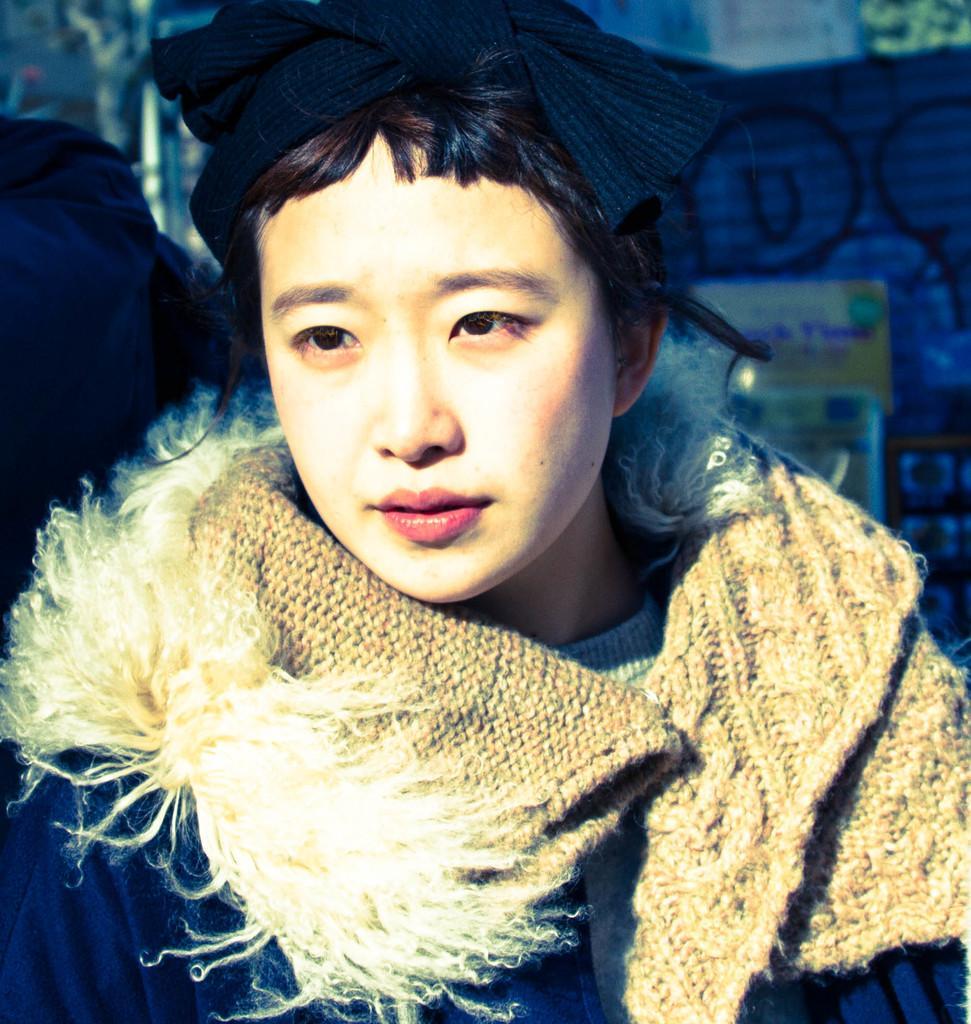Can you describe this image briefly? In the center of the image we can see a person wearing a jacket. In the background there is a wall and we can see a graffiti on the wall. 